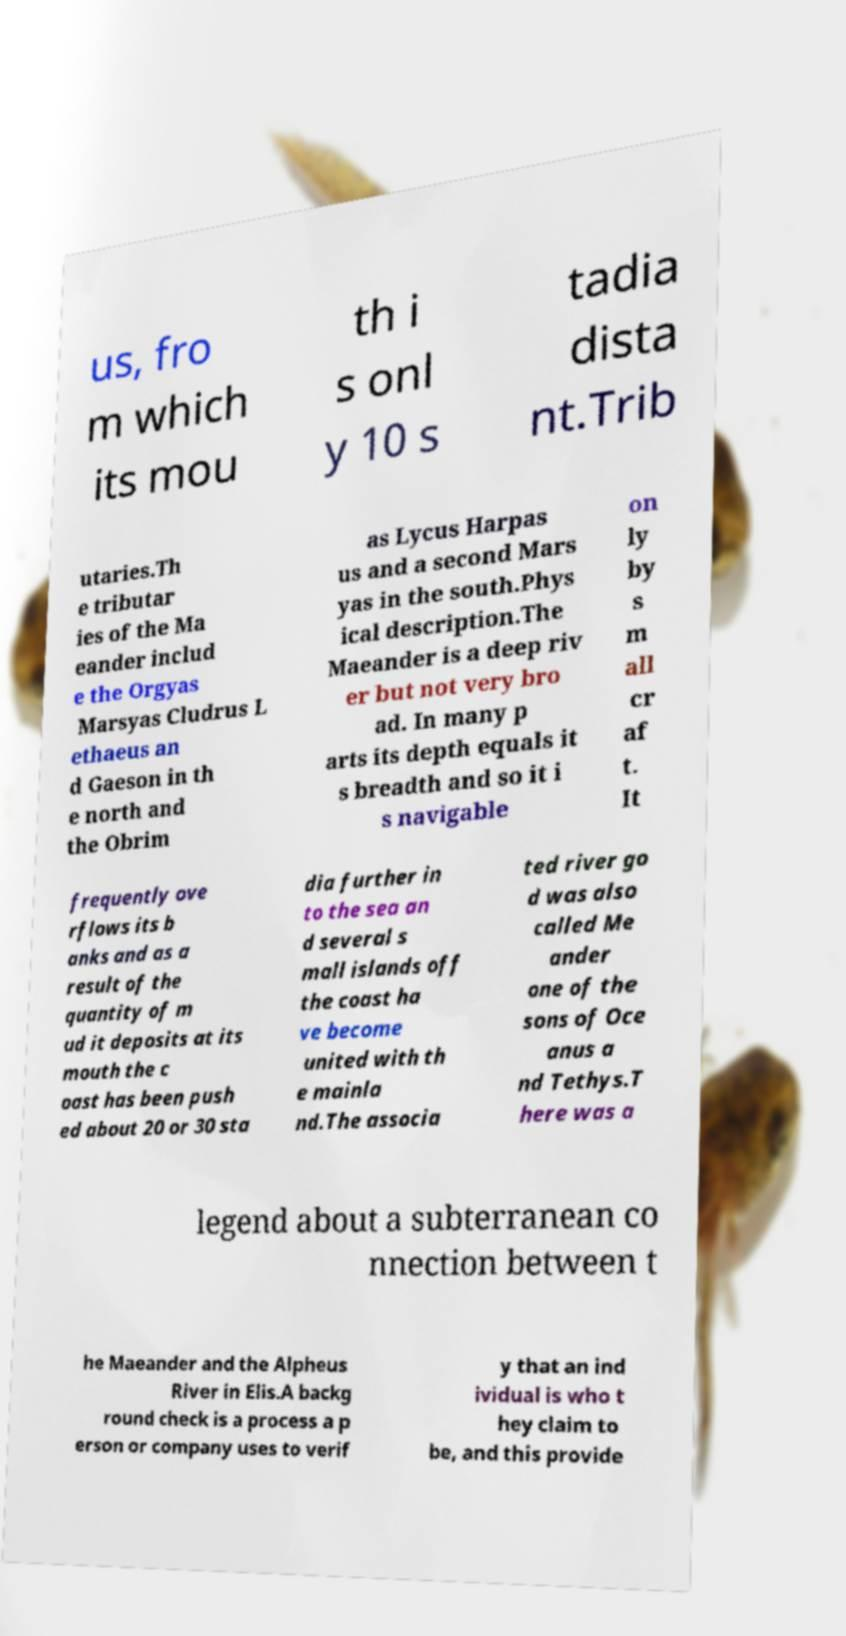Can you read and provide the text displayed in the image?This photo seems to have some interesting text. Can you extract and type it out for me? us, fro m which its mou th i s onl y 10 s tadia dista nt.Trib utaries.Th e tributar ies of the Ma eander includ e the Orgyas Marsyas Cludrus L ethaeus an d Gaeson in th e north and the Obrim as Lycus Harpas us and a second Mars yas in the south.Phys ical description.The Maeander is a deep riv er but not very bro ad. In many p arts its depth equals it s breadth and so it i s navigable on ly by s m all cr af t. It frequently ove rflows its b anks and as a result of the quantity of m ud it deposits at its mouth the c oast has been push ed about 20 or 30 sta dia further in to the sea an d several s mall islands off the coast ha ve become united with th e mainla nd.The associa ted river go d was also called Me ander one of the sons of Oce anus a nd Tethys.T here was a legend about a subterranean co nnection between t he Maeander and the Alpheus River in Elis.A backg round check is a process a p erson or company uses to verif y that an ind ividual is who t hey claim to be, and this provide 